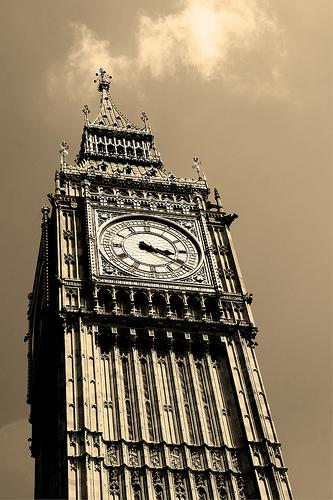What is the primary feature of the sky in this image? The sky in this image is gloomy and gray with a lot of white clouds. What does the image's sentiment evoke, considering the weather conditions and the filter applied? The image has a nostalgic and somewhat melancholic sentiment, given the bad weather, gloomy gray sky, and sepia filter applied. Examine the image and provide an observation about the clock's design elements. The clock has a white face, Roman numerals for numbers, black hands, a square frame, and a round design within the framing, overall making it look fancy and eye-catching. Identify the main object in the image and its primary characteristic. The main object in the image is an old clock tower with a large, round clock face and Roman numerals. Provide a brief description of the tower focusing on its architectural features. The clock tower is tall, antique, and beautifully decorated with elements such as statues, a sloped roof, and a peaked top. How many statues can be seen in the picture, and where are they located? There are two sets of statues on the tower: one set near the top of the tower, and the other set lower down, both contributing to the tower's ornate appearance. Analyze the interaction between the clock and the tower in the image. The clock is located near the top of the tower, mounted within a square frame, surrounded by intricate decorations and statues, showcasing the overall aesthetic of the tower. How many clocks can be seen in the image, and what is their appearance like? Only one clock is visible in the image, which is fancy and has a round face with Roman numerals, black hands, and a square frame. Provide a statement about the image, focusing on the overall size and appearance of the clock tower. The image showcases a huge, tall, and beautiful clock tower, adorned with decorations and featuring an old and fancy clock face. Based on the information provided, determine the time displayed on the clock and describe the hands. The time displayed on the clock says 3:20, with black hands indicating the hours and minutes. 